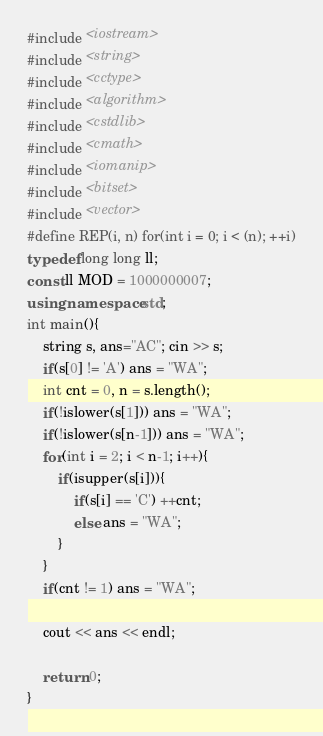Convert code to text. <code><loc_0><loc_0><loc_500><loc_500><_C++_>#include <iostream>
#include <string>
#include <cctype>
#include <algorithm>
#include <cstdlib>
#include <cmath>
#include <iomanip>
#include <bitset>
#include <vector>
#define REP(i, n) for(int i = 0; i < (n); ++i)
typedef long long ll;
const ll MOD = 1000000007;
using namespace std;
int main(){
    string s, ans="AC"; cin >> s;
    if(s[0] != 'A') ans = "WA";
    int cnt = 0, n = s.length();
    if(!islower(s[1])) ans = "WA";
    if(!islower(s[n-1])) ans = "WA";
    for(int i = 2; i < n-1; i++){
        if(isupper(s[i])){
            if(s[i] == 'C') ++cnt;
            else ans = "WA";
        }
    }
    if(cnt != 1) ans = "WA";
    
    cout << ans << endl;
    
    return 0;
}
</code> 